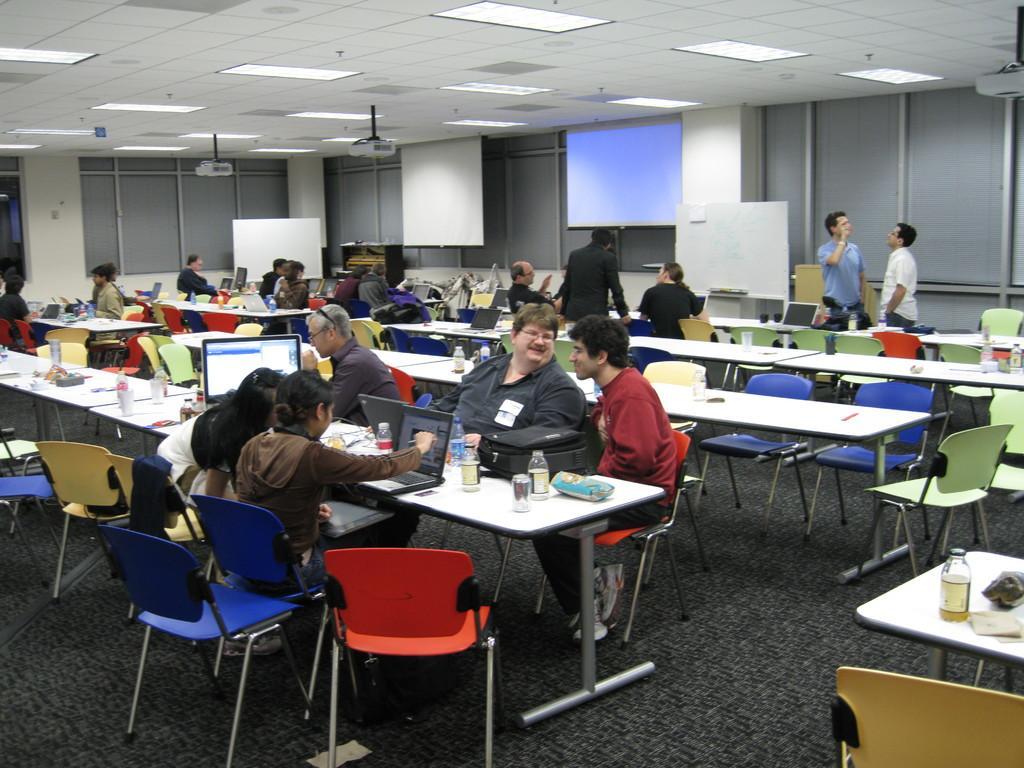Please provide a concise description of this image. In this picture there are group of people those who are sitting on the chairs, in the rows of tables, there are some bottles, glasses, and papers on the tables and there is a white color ceiling on the roof, there is a window at the left side of the image around the area and there is a projector screen at the right side of the image. 